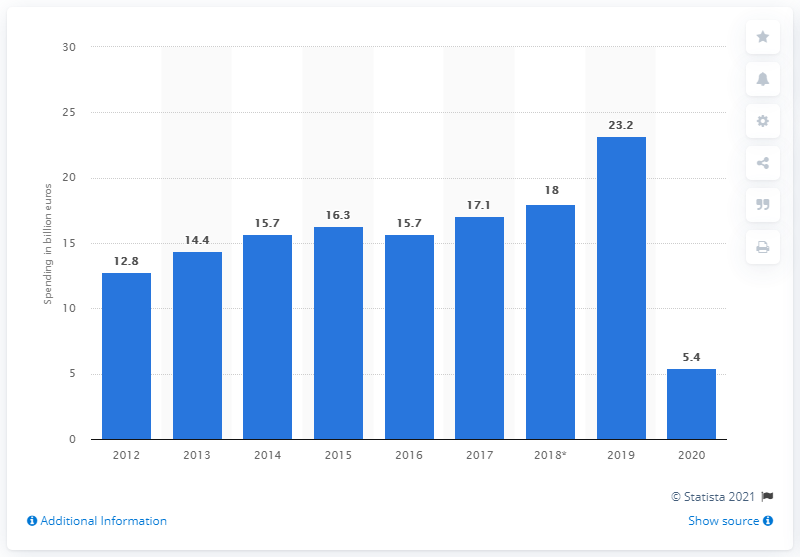Indicate a few pertinent items in this graphic. In 2019, the amount of tourism spending in Greece was 23.2 million. Greece's tourism spending in 2020 was estimated to be 5.4 billion. 